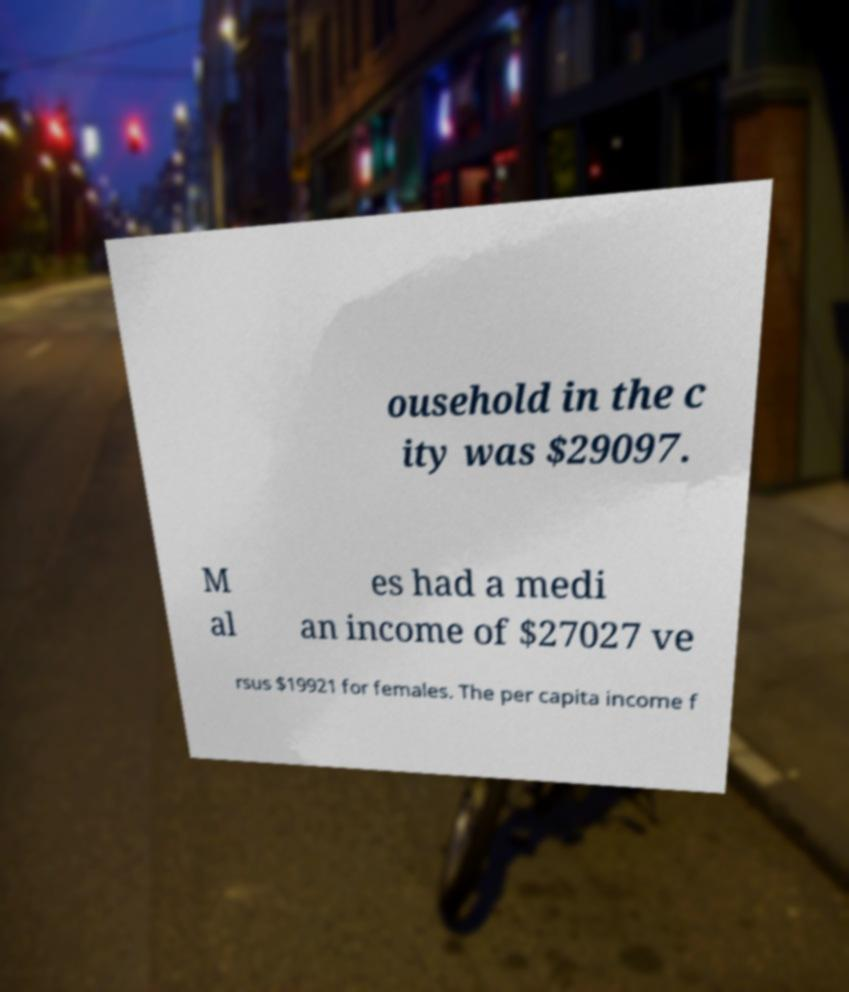I need the written content from this picture converted into text. Can you do that? ousehold in the c ity was $29097. M al es had a medi an income of $27027 ve rsus $19921 for females. The per capita income f 